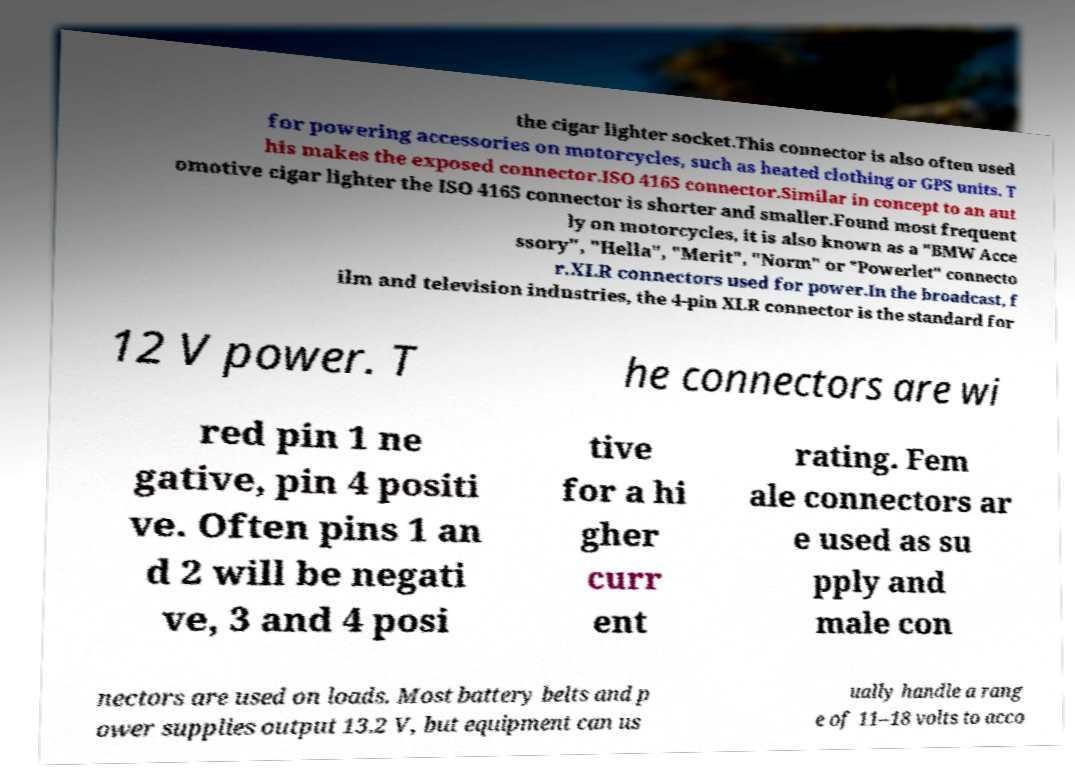For documentation purposes, I need the text within this image transcribed. Could you provide that? the cigar lighter socket.This connector is also often used for powering accessories on motorcycles, such as heated clothing or GPS units. T his makes the exposed connector.ISO 4165 connector.Similar in concept to an aut omotive cigar lighter the ISO 4165 connector is shorter and smaller.Found most frequent ly on motorcycles, it is also known as a "BMW Acce ssory", "Hella", "Merit", "Norm" or "Powerlet" connecto r.XLR connectors used for power.In the broadcast, f ilm and television industries, the 4-pin XLR connector is the standard for 12 V power. T he connectors are wi red pin 1 ne gative, pin 4 positi ve. Often pins 1 an d 2 will be negati ve, 3 and 4 posi tive for a hi gher curr ent rating. Fem ale connectors ar e used as su pply and male con nectors are used on loads. Most battery belts and p ower supplies output 13.2 V, but equipment can us ually handle a rang e of 11–18 volts to acco 